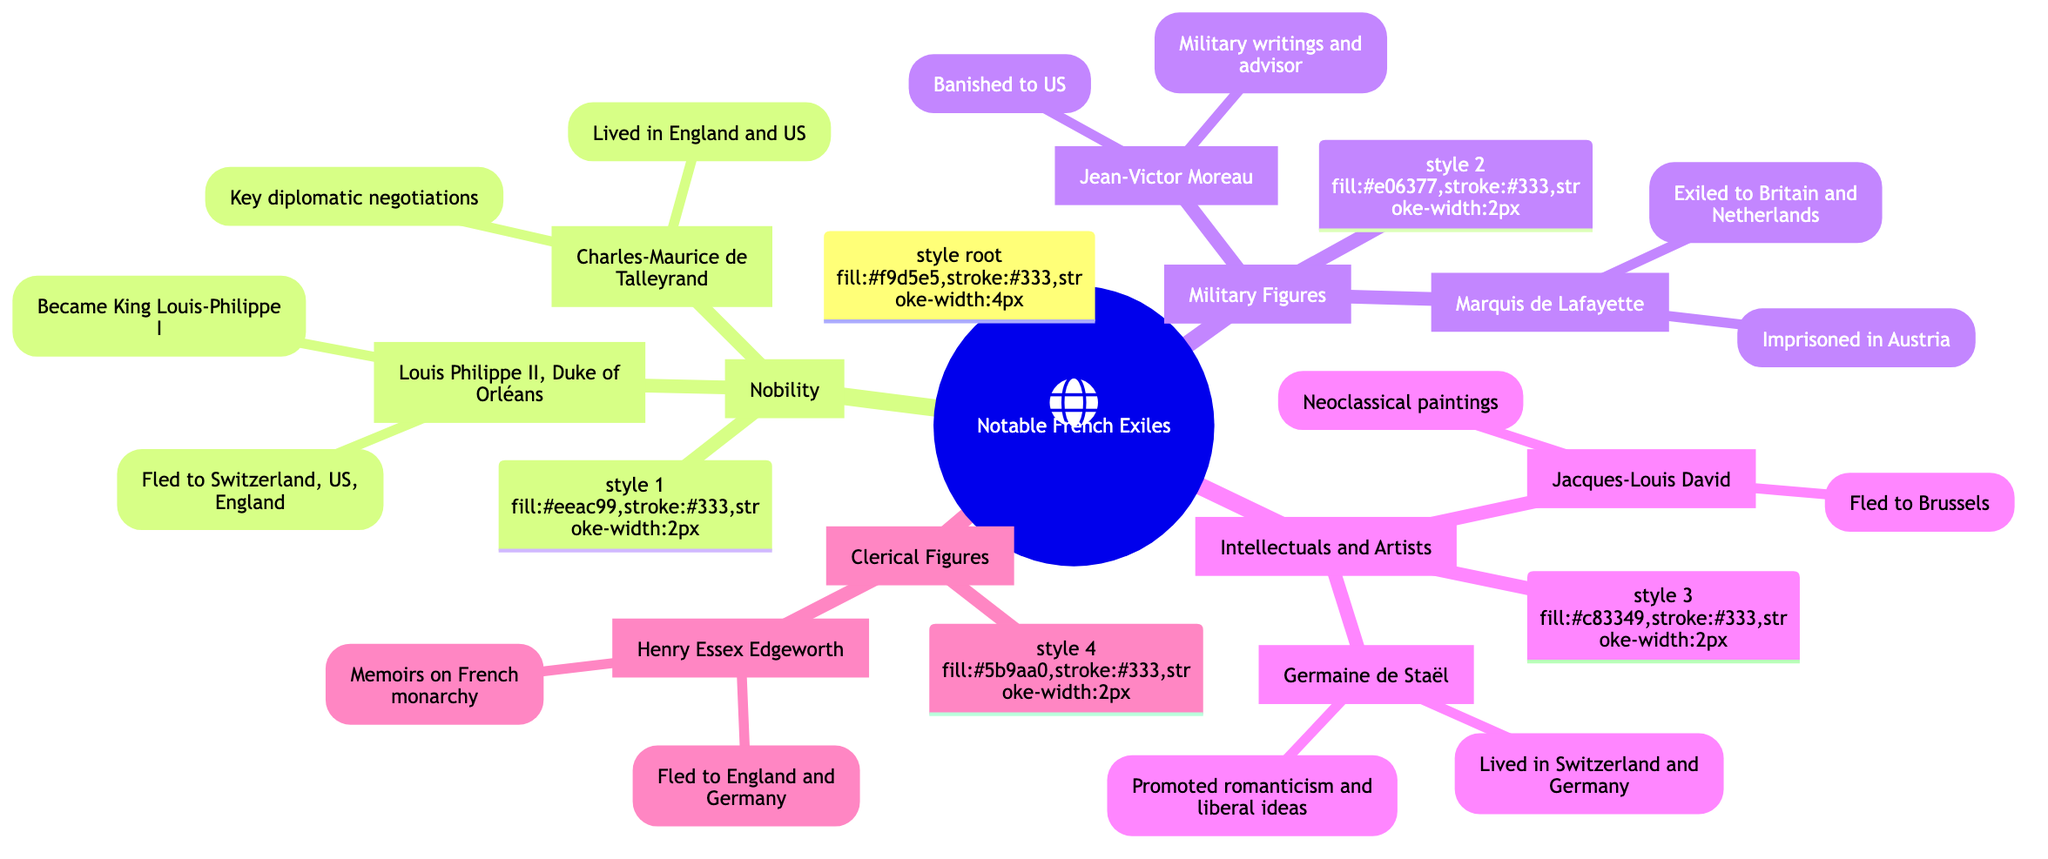What is the contribution of Louis Philippe II, Duke of Orléans? According to the Mind Map, he later became King Louis-Philippe I and had writings and political influence while in exile. Therefore, his key contributions were both political and literary in exile.
Answer: Writings and political influence in exile, later became King Louis-Philippe I What is the exile location of Germaine de Staël? The diagram states that Germaine de Staël lived in Switzerland and Germany due to her opposition to Napoleon. Thus, these are her primary locations of exile.
Answer: Switzerland and Germany How many notable figures are listed under the category of Nobility? Looking at the Mind Map under the Nobility section, there are two figures listed: Louis Philippe II, Duke of Orléans and Charles-Maurice de Talleyrand. Thus, the total is two.
Answer: 2 Who documented and shaped public perception of the Revolution through artistic works? The Mind Map indicates that Jacques-Louis David was a prominent neoclassical painter whose artistic works influenced public perception of the Revolution, thus he is the individual noted for this role.
Answer: Jacques-Louis David What common background did Jean-Victor Moreau and Gilbert du Motier, Marquis de Lafayette share? The diagram indicates that both figures were military personalities; Moreau was a distinguished general and Lafayette was a hero of both the American and French Revolutions. This commonality identifies them as notable military figures.
Answer: Military figures 